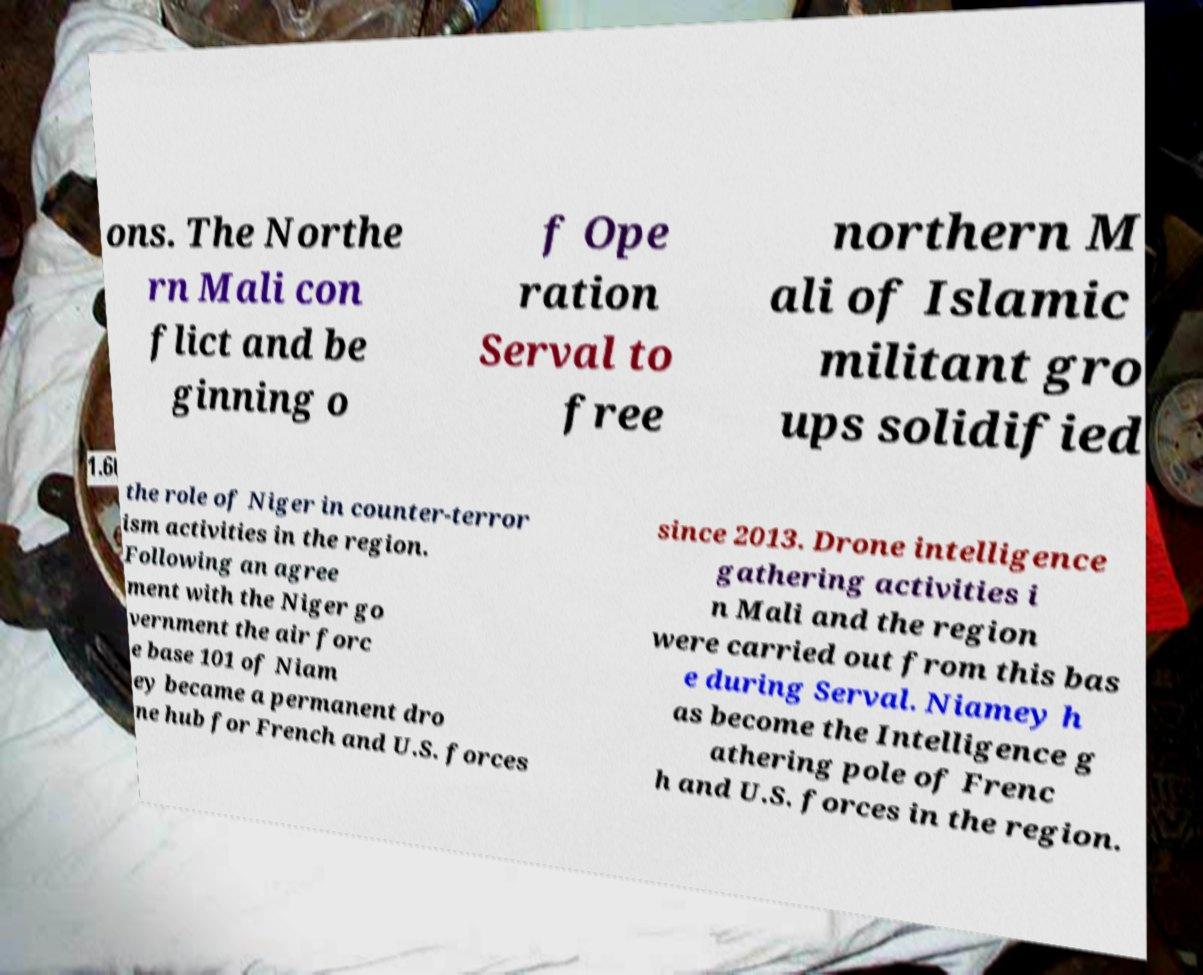For documentation purposes, I need the text within this image transcribed. Could you provide that? ons. The Northe rn Mali con flict and be ginning o f Ope ration Serval to free northern M ali of Islamic militant gro ups solidified the role of Niger in counter-terror ism activities in the region. Following an agree ment with the Niger go vernment the air forc e base 101 of Niam ey became a permanent dro ne hub for French and U.S. forces since 2013. Drone intelligence gathering activities i n Mali and the region were carried out from this bas e during Serval. Niamey h as become the Intelligence g athering pole of Frenc h and U.S. forces in the region. 